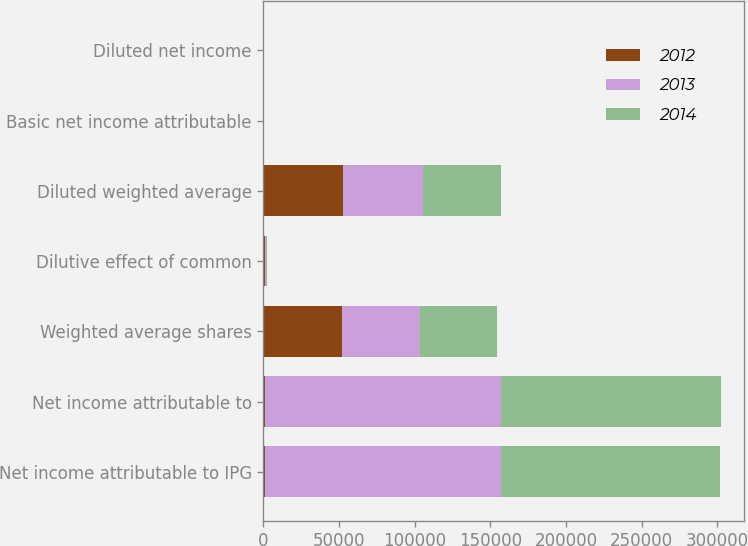<chart> <loc_0><loc_0><loc_500><loc_500><stacked_bar_chart><ecel><fcel>Net income attributable to IPG<fcel>Net income attributable to<fcel>Weighted average shares<fcel>Dilutive effect of common<fcel>Diluted weighted average<fcel>Basic net income attributable<fcel>Diluted net income<nl><fcel>2012<fcel>943<fcel>943<fcel>52104<fcel>720<fcel>52824<fcel>3.85<fcel>3.79<nl><fcel>2013<fcel>155780<fcel>155780<fcel>51548<fcel>827<fcel>52375<fcel>3.02<fcel>2.97<nl><fcel>2014<fcel>145004<fcel>145497<fcel>50477<fcel>1059<fcel>51536<fcel>2.87<fcel>2.8<nl></chart> 